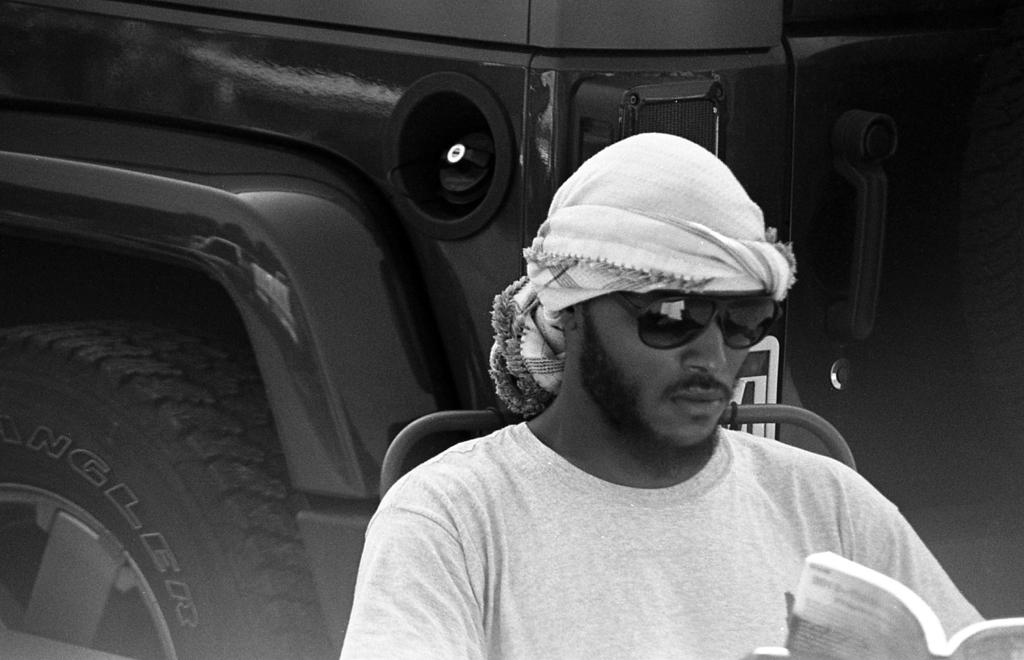What is the main subject in the foreground of the image? There is a person in the foreground of the image. What is the person doing in the image? The person is sitting and reading something. Can you describe the background of the image? There is a vehicle in the background of the image. What type of cake is the person's mother holding in the image? There is no cake or person's mother present in the image. How many sacks can be seen in the image? There are no sacks visible in the image. 